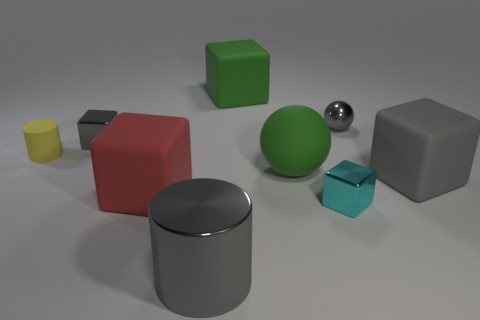Do the big cylinder and the big object that is right of the gray metallic sphere have the same color?
Provide a succinct answer. Yes. There is a block that is the same color as the matte sphere; what material is it?
Ensure brevity in your answer.  Rubber. There is a green sphere that is the same size as the shiny cylinder; what material is it?
Your response must be concise. Rubber. Are there any green objects that have the same size as the gray shiny cube?
Ensure brevity in your answer.  No. What color is the small rubber cylinder behind the large cylinder?
Provide a short and direct response. Yellow. Is there a green cube in front of the big gray block behind the small cyan shiny thing?
Make the answer very short. No. What number of other objects are there of the same color as the metallic cylinder?
Your response must be concise. 3. There is a gray metallic object right of the big gray metallic object; does it have the same size as the gray block right of the big gray metallic thing?
Your answer should be compact. No. What is the size of the cylinder on the right side of the gray shiny cube behind the red rubber block?
Give a very brief answer. Large. What is the cube that is both behind the big gray block and on the left side of the big green cube made of?
Provide a short and direct response. Metal. 